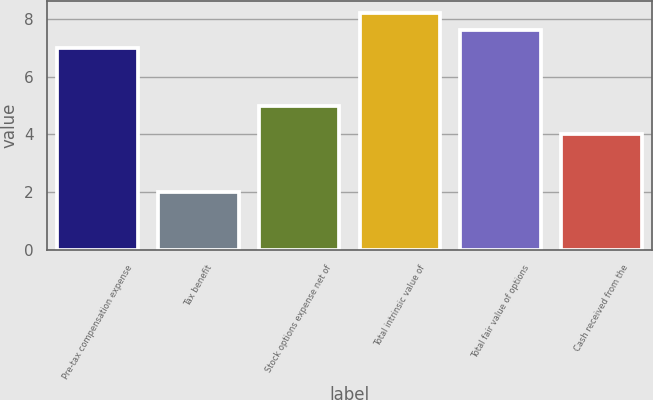Convert chart. <chart><loc_0><loc_0><loc_500><loc_500><bar_chart><fcel>Pre-tax compensation expense<fcel>Tax benefit<fcel>Stock options expense net of<fcel>Total intrinsic value of<fcel>Total fair value of options<fcel>Cash received from the<nl><fcel>7<fcel>2<fcel>5<fcel>8.2<fcel>7.6<fcel>4<nl></chart> 